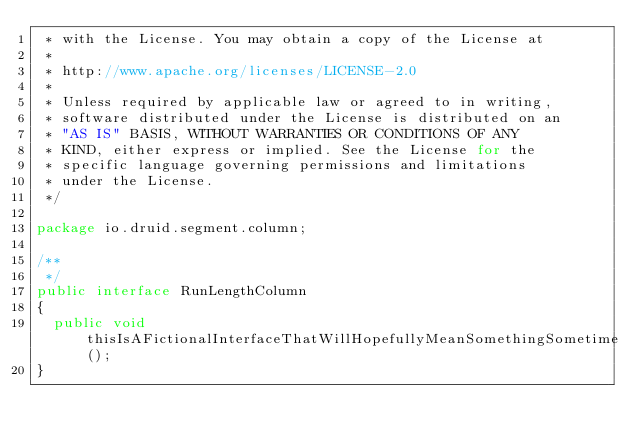<code> <loc_0><loc_0><loc_500><loc_500><_Java_> * with the License. You may obtain a copy of the License at
 *
 * http://www.apache.org/licenses/LICENSE-2.0
 *
 * Unless required by applicable law or agreed to in writing,
 * software distributed under the License is distributed on an
 * "AS IS" BASIS, WITHOUT WARRANTIES OR CONDITIONS OF ANY
 * KIND, either express or implied. See the License for the
 * specific language governing permissions and limitations
 * under the License.
 */

package io.druid.segment.column;

/**
 */
public interface RunLengthColumn
{
  public void thisIsAFictionalInterfaceThatWillHopefullyMeanSomethingSometime();
}
</code> 